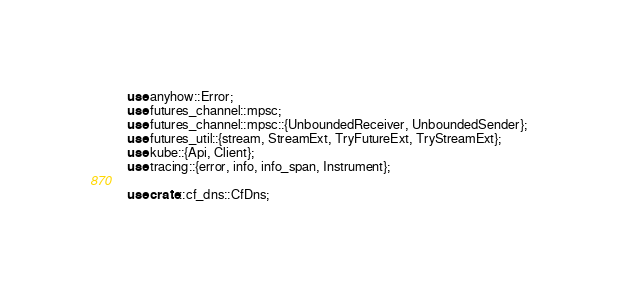<code> <loc_0><loc_0><loc_500><loc_500><_Rust_>use anyhow::Error;
use futures_channel::mpsc;
use futures_channel::mpsc::{UnboundedReceiver, UnboundedSender};
use futures_util::{stream, StreamExt, TryFutureExt, TryStreamExt};
use kube::{Api, Client};
use tracing::{error, info, info_span, Instrument};

use crate::cf_dns::CfDns;</code> 